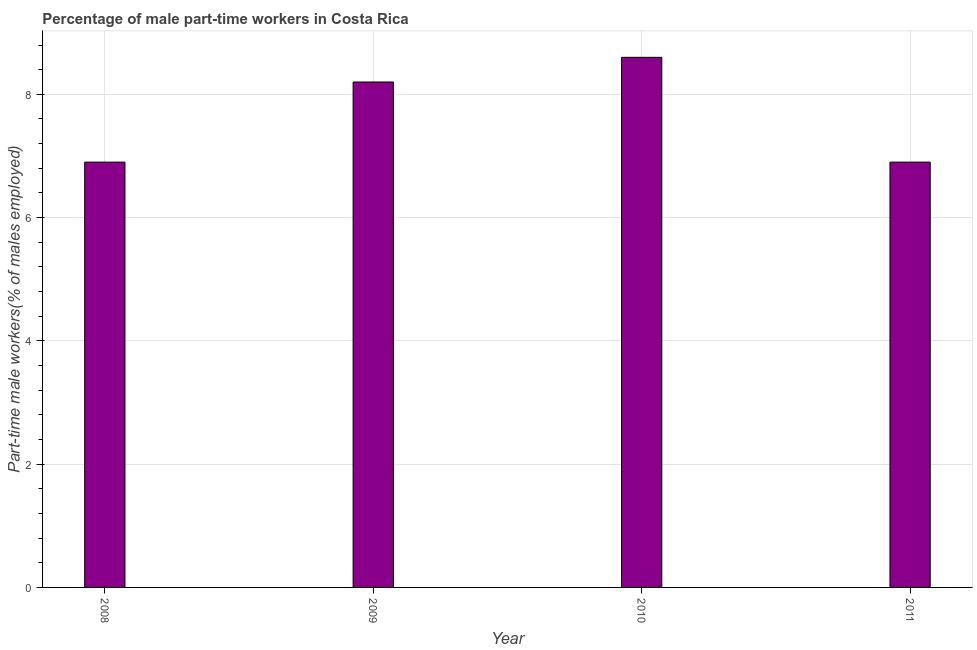Does the graph contain grids?
Give a very brief answer. Yes. What is the title of the graph?
Keep it short and to the point. Percentage of male part-time workers in Costa Rica. What is the label or title of the Y-axis?
Your response must be concise. Part-time male workers(% of males employed). What is the percentage of part-time male workers in 2011?
Your answer should be compact. 6.9. Across all years, what is the maximum percentage of part-time male workers?
Provide a succinct answer. 8.6. Across all years, what is the minimum percentage of part-time male workers?
Give a very brief answer. 6.9. In which year was the percentage of part-time male workers maximum?
Make the answer very short. 2010. In which year was the percentage of part-time male workers minimum?
Ensure brevity in your answer.  2008. What is the sum of the percentage of part-time male workers?
Your response must be concise. 30.6. What is the difference between the percentage of part-time male workers in 2008 and 2010?
Offer a terse response. -1.7. What is the average percentage of part-time male workers per year?
Your response must be concise. 7.65. What is the median percentage of part-time male workers?
Ensure brevity in your answer.  7.55. Do a majority of the years between 2008 and 2009 (inclusive) have percentage of part-time male workers greater than 4.4 %?
Your answer should be compact. Yes. What is the ratio of the percentage of part-time male workers in 2009 to that in 2011?
Give a very brief answer. 1.19. Is the percentage of part-time male workers in 2009 less than that in 2010?
Offer a terse response. Yes. What is the difference between the highest and the second highest percentage of part-time male workers?
Your response must be concise. 0.4. Is the sum of the percentage of part-time male workers in 2009 and 2011 greater than the maximum percentage of part-time male workers across all years?
Give a very brief answer. Yes. What is the difference between two consecutive major ticks on the Y-axis?
Ensure brevity in your answer.  2. Are the values on the major ticks of Y-axis written in scientific E-notation?
Your answer should be compact. No. What is the Part-time male workers(% of males employed) of 2008?
Your answer should be very brief. 6.9. What is the Part-time male workers(% of males employed) in 2009?
Provide a succinct answer. 8.2. What is the Part-time male workers(% of males employed) in 2010?
Provide a succinct answer. 8.6. What is the Part-time male workers(% of males employed) of 2011?
Offer a terse response. 6.9. What is the difference between the Part-time male workers(% of males employed) in 2008 and 2009?
Your answer should be compact. -1.3. What is the difference between the Part-time male workers(% of males employed) in 2009 and 2011?
Provide a short and direct response. 1.3. What is the difference between the Part-time male workers(% of males employed) in 2010 and 2011?
Ensure brevity in your answer.  1.7. What is the ratio of the Part-time male workers(% of males employed) in 2008 to that in 2009?
Make the answer very short. 0.84. What is the ratio of the Part-time male workers(% of males employed) in 2008 to that in 2010?
Your answer should be compact. 0.8. What is the ratio of the Part-time male workers(% of males employed) in 2008 to that in 2011?
Give a very brief answer. 1. What is the ratio of the Part-time male workers(% of males employed) in 2009 to that in 2010?
Provide a short and direct response. 0.95. What is the ratio of the Part-time male workers(% of males employed) in 2009 to that in 2011?
Keep it short and to the point. 1.19. What is the ratio of the Part-time male workers(% of males employed) in 2010 to that in 2011?
Give a very brief answer. 1.25. 